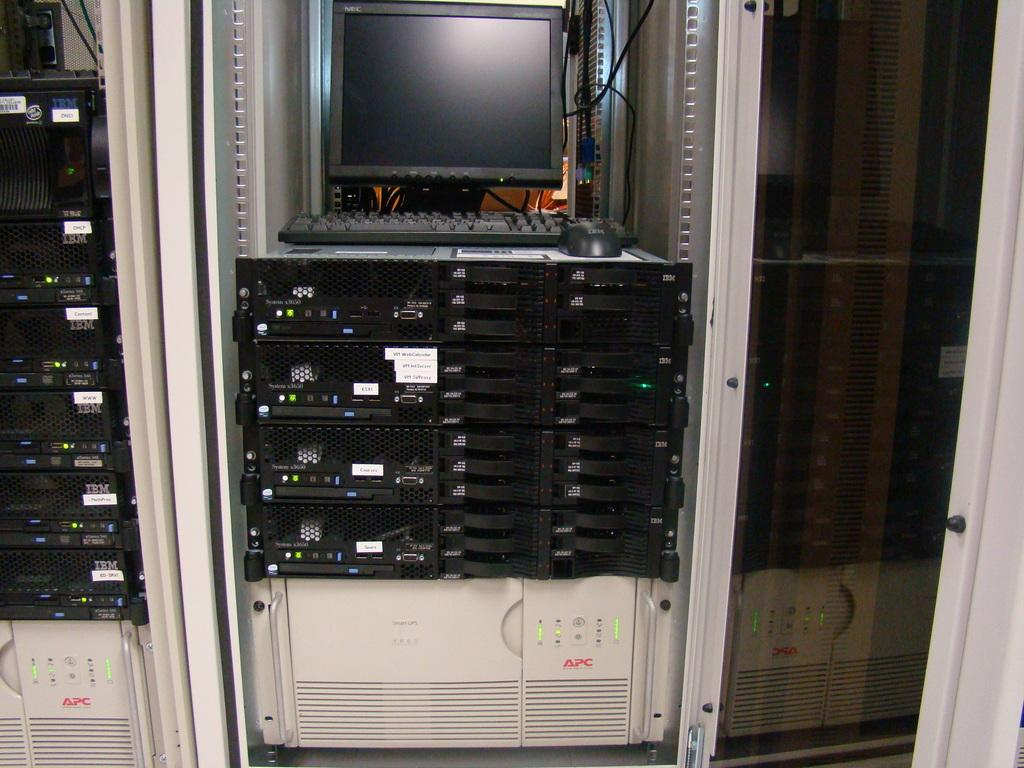What type of device is visible in the image? There is a monitor in the image. What is used for input in the image? There is a keyboard in the image. What is used for controlling the cursor on the monitor? There is a mouse in the image. What other devices or machines can be seen in the image? There are machines present in the image. What type of prose is being written on the monitor in the image? There is no prose visible on the monitor in the image. Can you tell me what type of insurance the person in the image has? There is no information about the person's insurance in the image. 